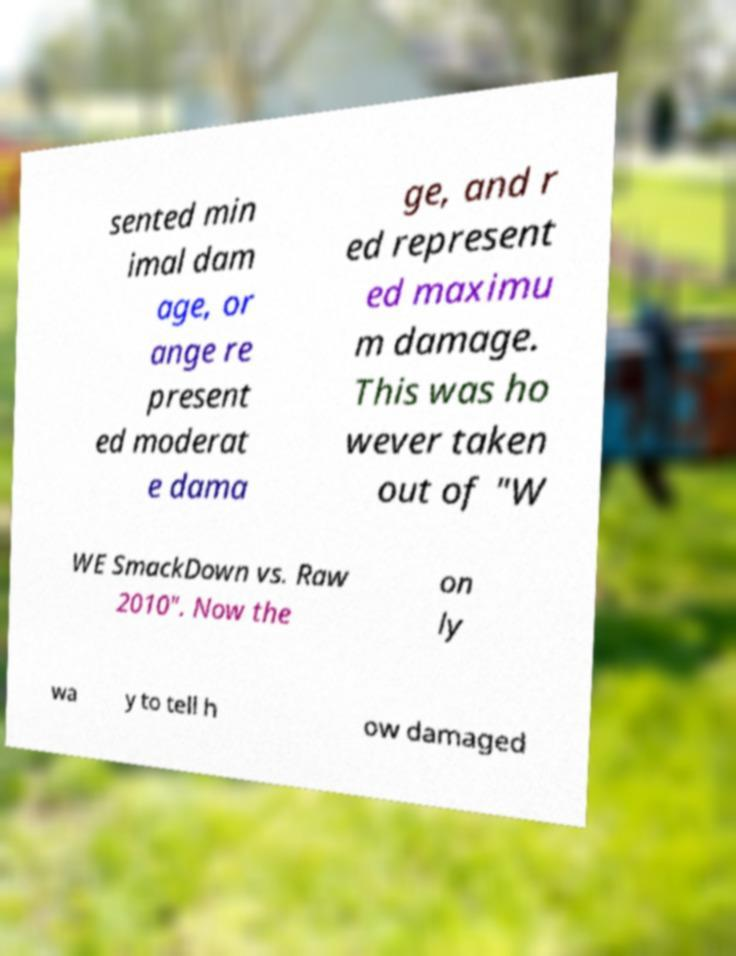Could you extract and type out the text from this image? sented min imal dam age, or ange re present ed moderat e dama ge, and r ed represent ed maximu m damage. This was ho wever taken out of "W WE SmackDown vs. Raw 2010". Now the on ly wa y to tell h ow damaged 